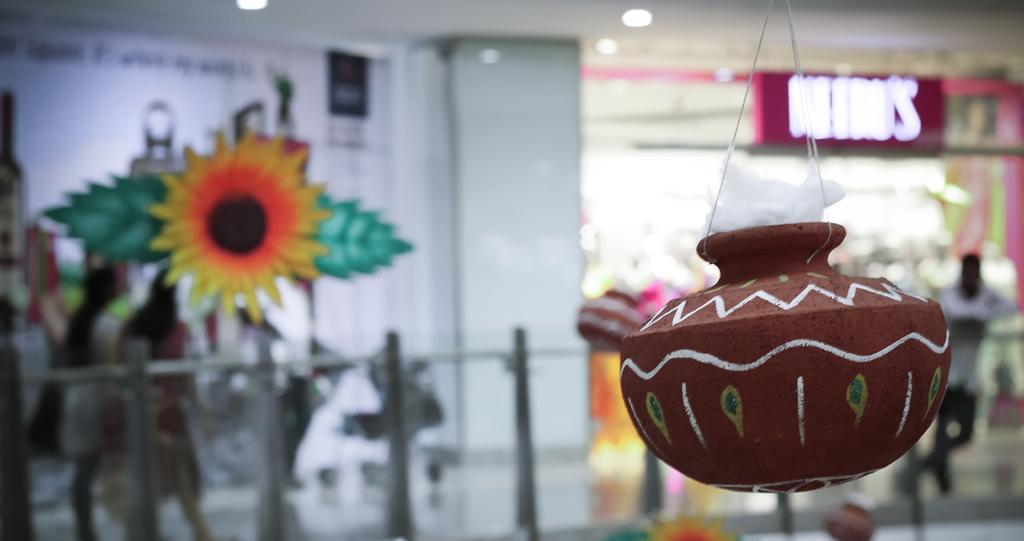Describe this image in one or two sentences. In this image there is a pot with some cotton hanging from the top, there is a poster with some text attached to the wall, a fence, few people and there is shop, there is a name board at the front of the shop. 